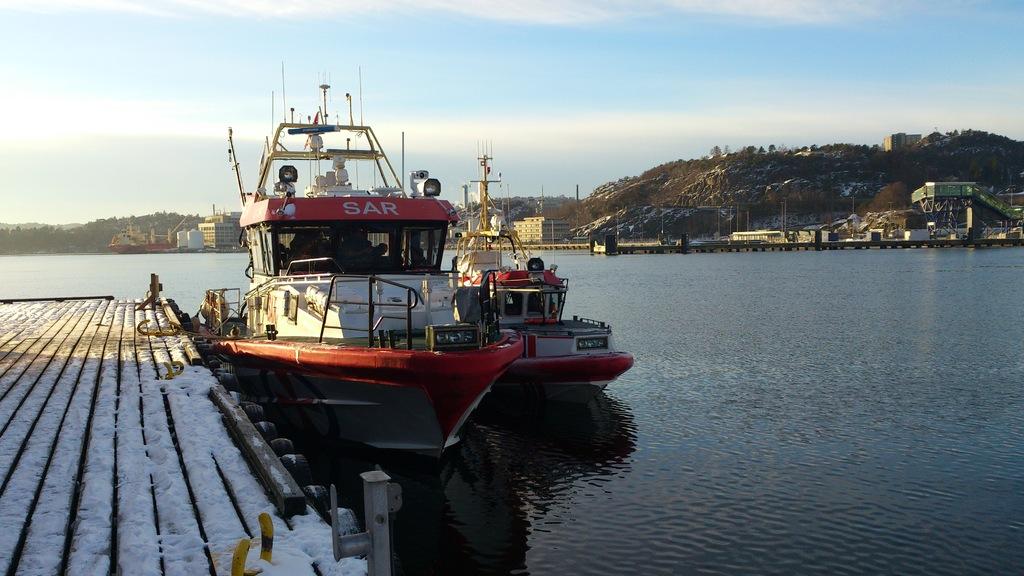What is written on the red banner on the boat?
Your answer should be very brief. Sar. What is the name of the boat?
Keep it short and to the point. Sar. 